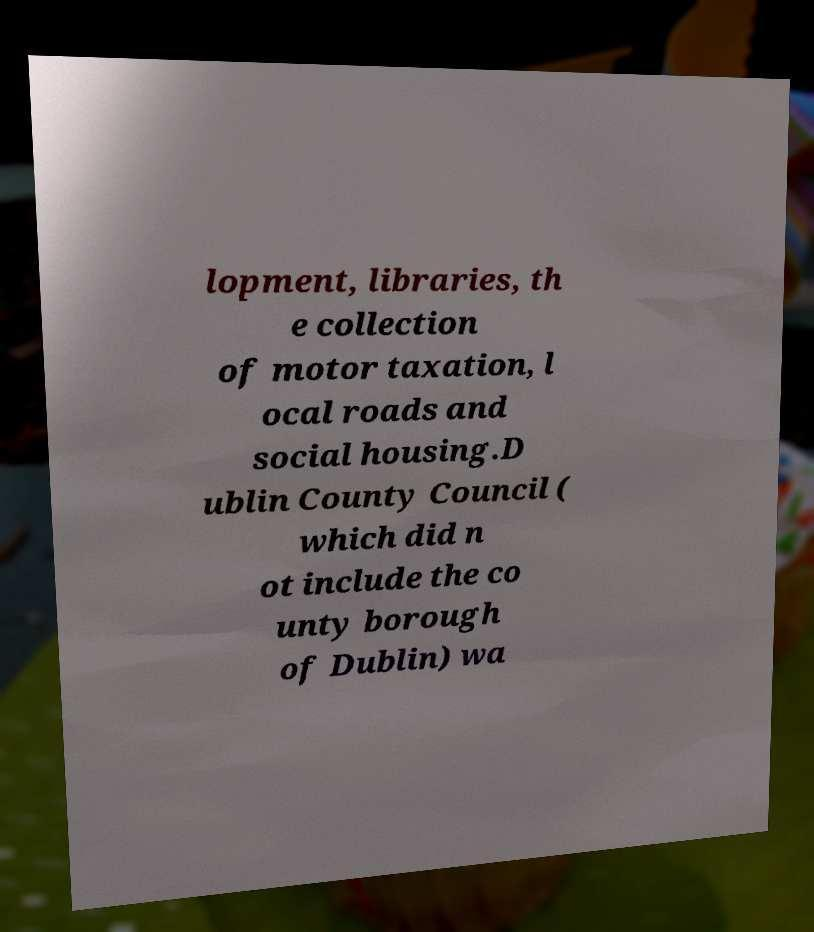Could you assist in decoding the text presented in this image and type it out clearly? lopment, libraries, th e collection of motor taxation, l ocal roads and social housing.D ublin County Council ( which did n ot include the co unty borough of Dublin) wa 